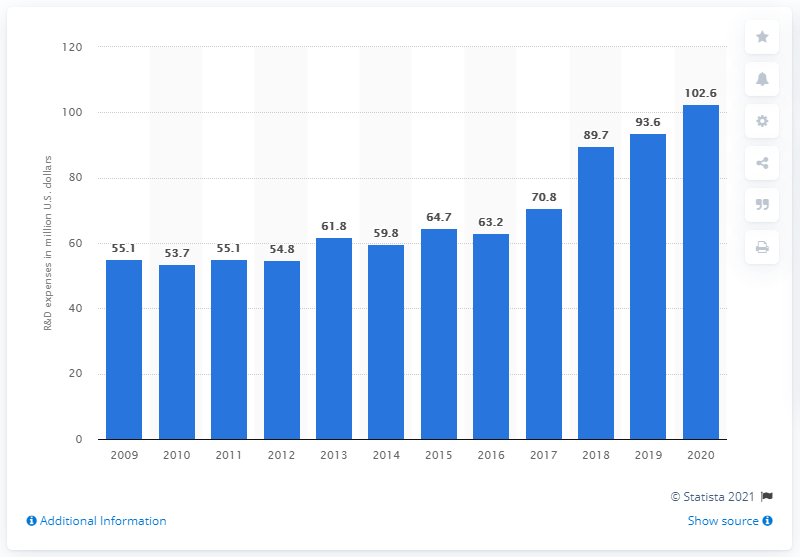Identify some key points in this picture. In 2020, Church & Dwight's global R&D expenditure was $102.6 million. 